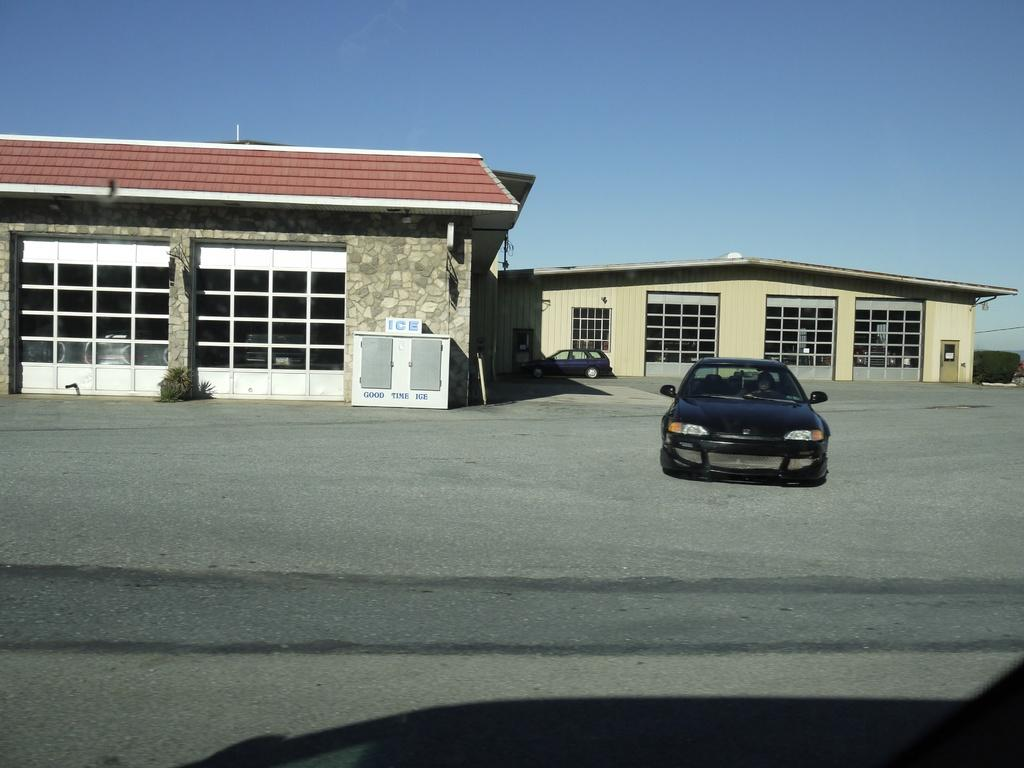What is the main subject of the image? There is a car in the image. What color is the car? The car is black in color. Where is the car located? The car is on the road. What can be seen in the background of the image? There are two buildings and a black colored car in the background of the image. What is visible in the sky in the image? The sky is visible in the background of the image. Can you see a fight between two people in the image? There is no fight between two people visible in the image. What type of hammer is being used to fix the car in the image? There is no hammer present in the image, and the car does not appear to be in need of repair. 